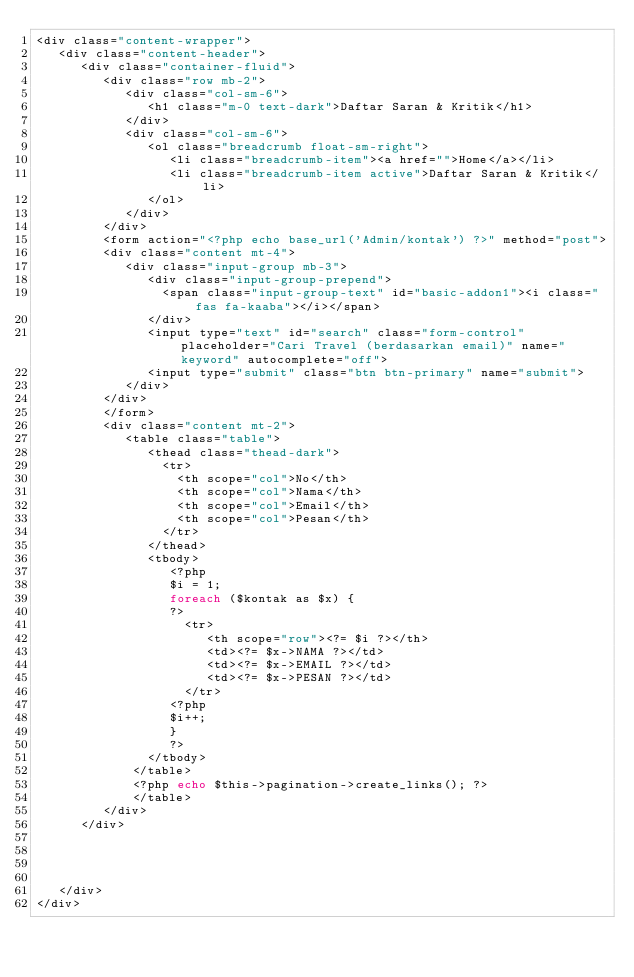Convert code to text. <code><loc_0><loc_0><loc_500><loc_500><_PHP_><div class="content-wrapper">
   <div class="content-header">
      <div class="container-fluid">
         <div class="row mb-2">
            <div class="col-sm-6">
               <h1 class="m-0 text-dark">Daftar Saran & Kritik</h1>
            </div>
            <div class="col-sm-6">
               <ol class="breadcrumb float-sm-right">
                  <li class="breadcrumb-item"><a href="">Home</a></li>
                  <li class="breadcrumb-item active">Daftar Saran & Kritik</li>
               </ol>
            </div>
         </div>
         <form action="<?php echo base_url('Admin/kontak') ?>" method="post">
         <div class="content mt-4">
            <div class="input-group mb-3">
               <div class="input-group-prepend">
                 <span class="input-group-text" id="basic-addon1"><i class="fas fa-kaaba"></i></span>
               </div>
               <input type="text" id="search" class="form-control" placeholder="Cari Travel (berdasarkan email)" name="keyword" autocomplete="off">
               <input type="submit" class="btn btn-primary" name="submit">
            </div>
         </div>
         </form>
         <div class="content mt-2">
            <table class="table">
               <thead class="thead-dark">
                 <tr>
                   <th scope="col">No</th>
                   <th scope="col">Nama</th>
                   <th scope="col">Email</th>
                   <th scope="col">Pesan</th>
                 </tr>
               </thead>
               <tbody>
                  <?php 
                  $i = 1;
                  foreach ($kontak as $x) { 
                  ?>
                    <tr>
                       <th scope="row"><?= $i ?></th>
                       <td><?= $x->NAMA ?></td>
                       <td><?= $x->EMAIL ?></td>
                       <td><?= $x->PESAN ?></td>
                    </tr>
                  <?php 
                  $i++;
                  }
                  ?>
               </tbody>
             </table>
             <?php echo $this->pagination->create_links(); ?>
             </table>
         </div>
      </div>
      



   </div>
</div>
</code> 